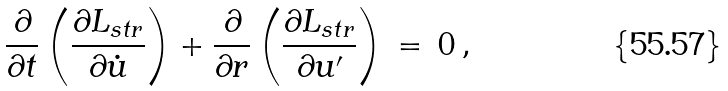Convert formula to latex. <formula><loc_0><loc_0><loc_500><loc_500>\frac { \partial } { \partial t } \left ( \frac { \partial L _ { s t r } } { \partial \dot { u } } \right ) + \frac { \partial } { \partial r } \left ( \frac { \partial L _ { s t r } } { \partial { u } ^ { \prime } } \right ) \, = \, 0 \, { , }</formula> 